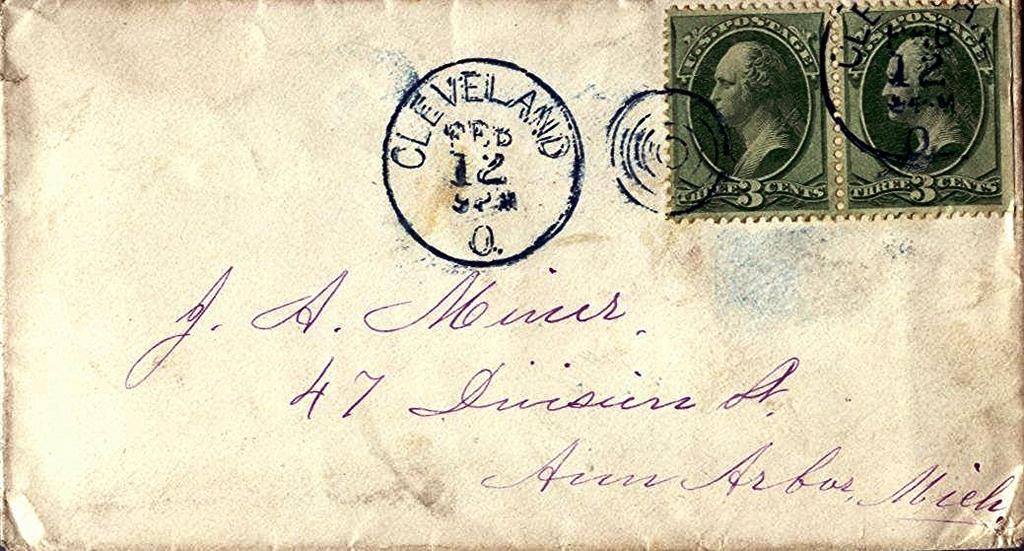<image>
Render a clear and concise summary of the photo. An envelope containing two stamps from Cleveland addressed to J.A. Noirur. 